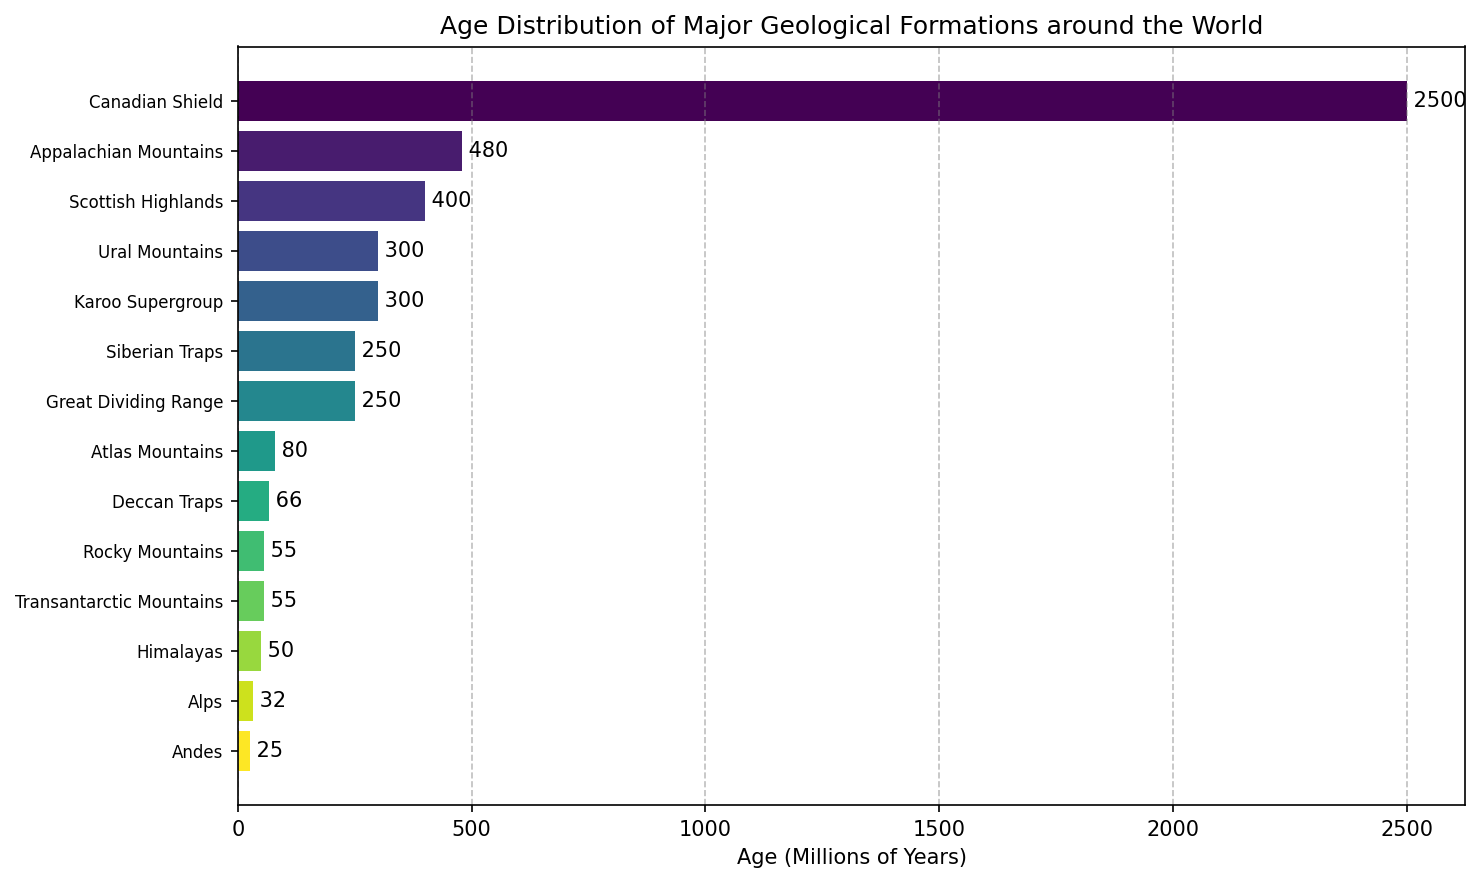Which geological formation is the oldest? The Canadian Shield has the highest bar, indicating it is the oldest.
Answer: Canadian Shield Which region has the highest number of formations represented in the figure? We need to count the number of formations per region: North America has three, Europe has three, Asia has three, while other regions have fewer.
Answer: North America, Europe, Asia (tie) What is the age difference between the youngest and oldest formation? The oldest formation is the Canadian Shield (2500 million years) and the youngest is the Andes (25 million years). Subtracting these gives 2500 - 25 = 2475.
Answer: 2475 million years Compare the ages of the Ural Mountains and the Himalayas. Which one is older? The Ural Mountains have an age of 300 million years, while the Himalayas are 50 million years old. Thus, the Urals are older.
Answer: Ural Mountains What is the total age when summing the ages of all formations in North America? The formations in North America are the Canadian Shield (2500 million years), Appalachian Mountains (480 million years), and Rocky Mountains (55 million years). Adding these gives 2500 + 480 + 55 = 3035 million years.
Answer: 3035 million years Which formation in Europe has the highest age? The bars for the Ural Mountains, Scottish Highlands, and Alps are compared, and the Scottish Highlands have the highest bar.
Answer: Scottish Highlands What is the average age of the formations listed for Asia? The formations in Asia and their ages are Himalayas (50 million years), Siberian Traps (250 million years), and Deccan Traps (66 million years). The sum is 50 + 250 + 66 = 366, and there are 3 formations, so the average is 366 / 3 = 122 million years.
Answer: 122 million years What is the combined age of the formations in Africa? The formations in Africa are the Karoo Supergroup (300 million years) and Atlas Mountains (80 million years). Adding these gives 300 + 80 = 380 million years.
Answer: 380 million years Which formation is exactly between the oldest and youngest formations when ordered by age? Ordering from oldest to youngest, the middle formation would be the Deccan Traps (5th formation counting from both ends).
Answer: Deccan Traps 